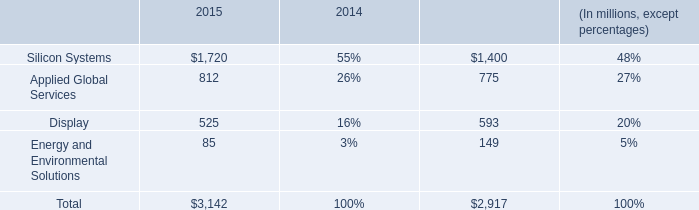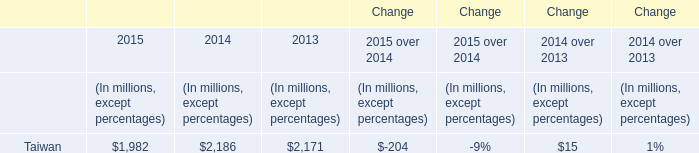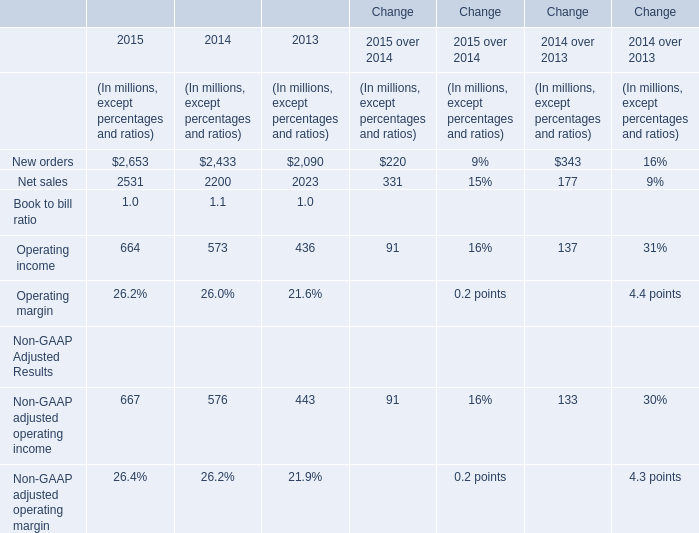What will Operating income be like in 2016 if it develops with the same increasing rate as current? (in million) 
Computations: ((1 + ((664 - 573) / 573)) * 664)
Answer: 769.45201. 